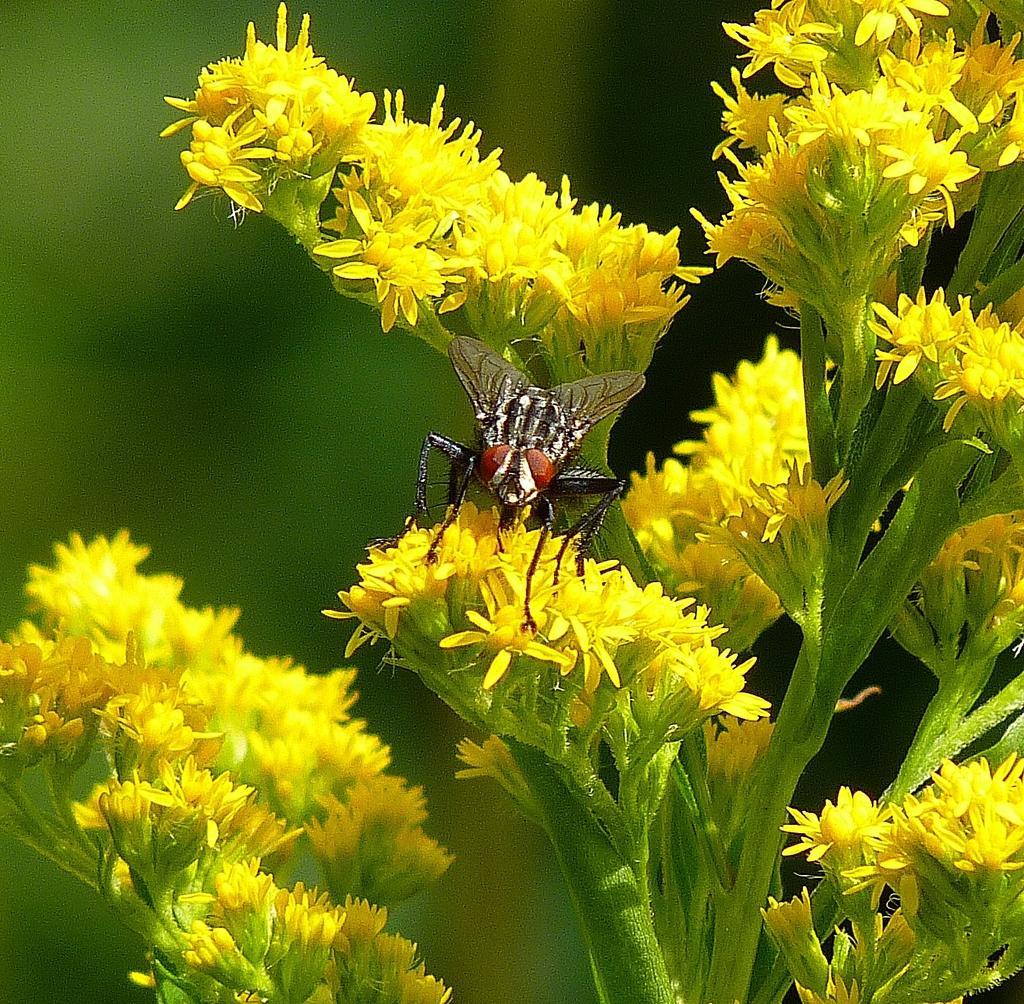How would you summarize this image in a sentence or two? In this picture we can see a few flowers on the stems. There is an insect visible on the flowers. Background is blurry. 